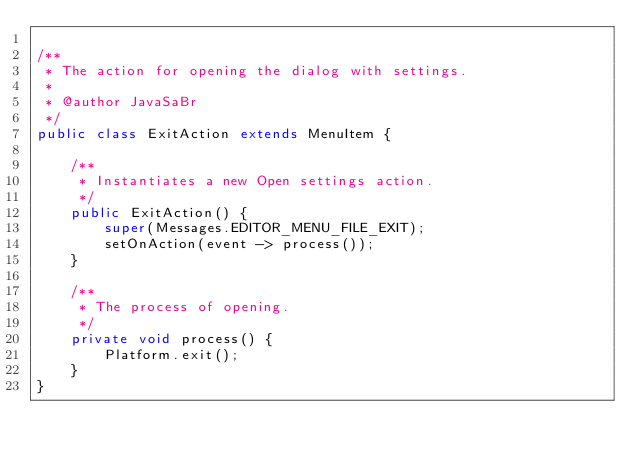<code> <loc_0><loc_0><loc_500><loc_500><_Java_>
/**
 * The action for opening the dialog with settings.
 *
 * @author JavaSaBr
 */
public class ExitAction extends MenuItem {

    /**
     * Instantiates a new Open settings action.
     */
    public ExitAction() {
        super(Messages.EDITOR_MENU_FILE_EXIT);
        setOnAction(event -> process());
    }

    /**
     * The process of opening.
     */
    private void process() {
        Platform.exit();
    }
}
</code> 